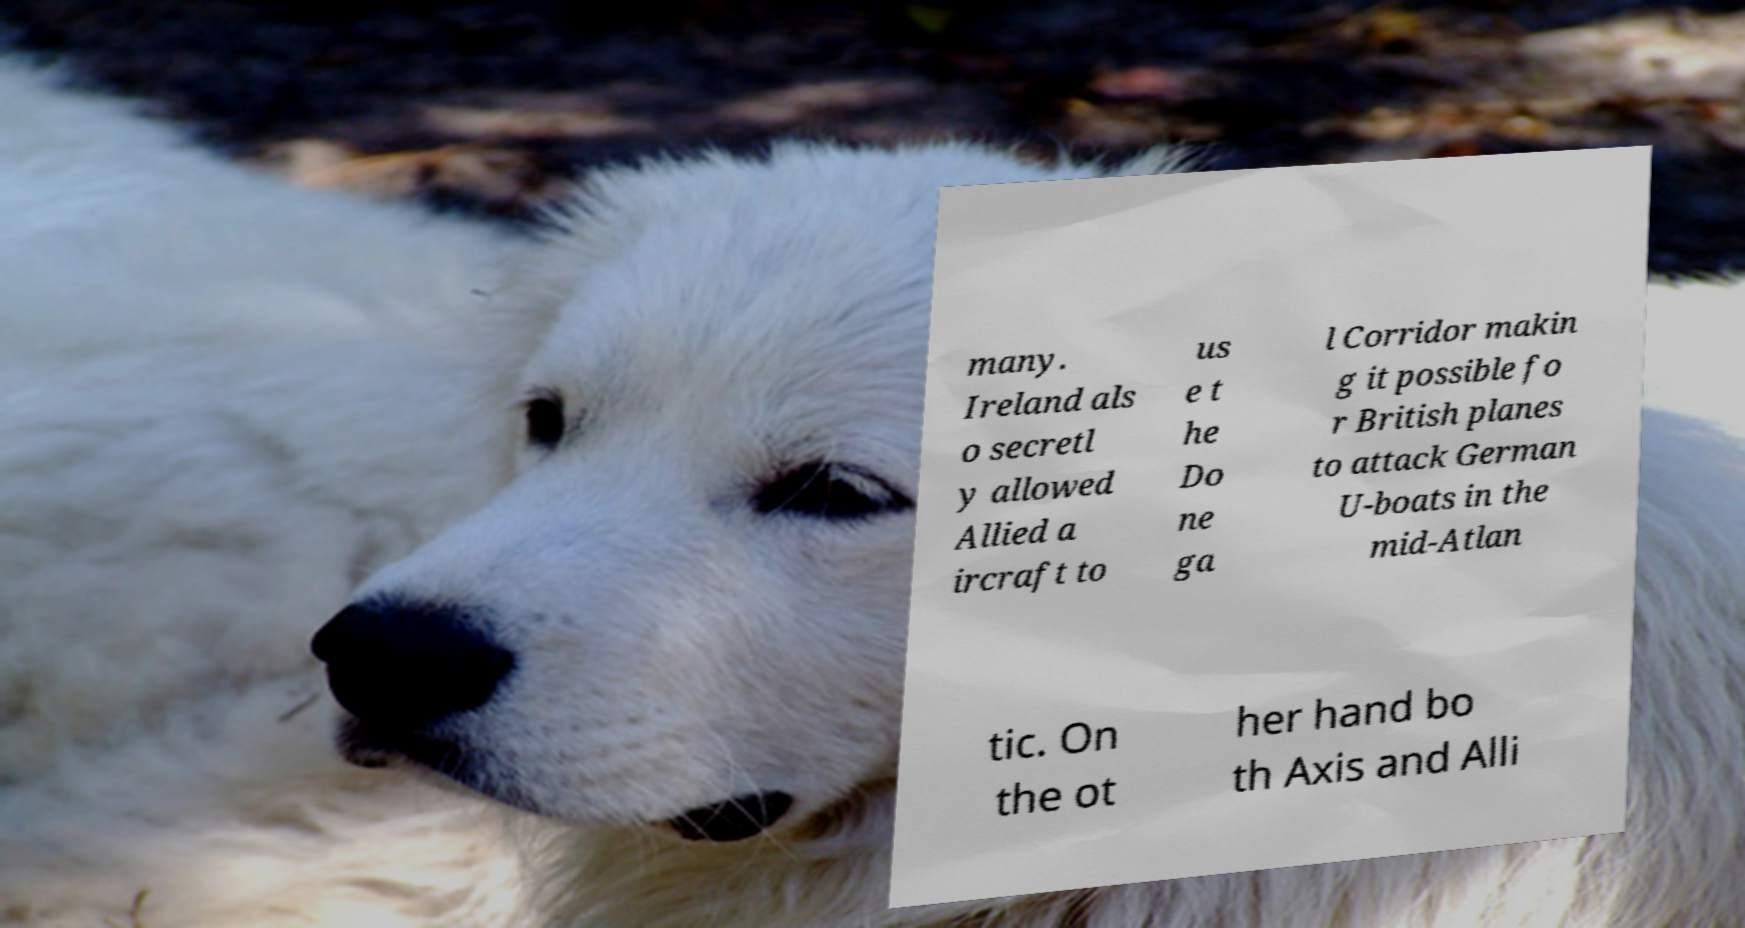I need the written content from this picture converted into text. Can you do that? many. Ireland als o secretl y allowed Allied a ircraft to us e t he Do ne ga l Corridor makin g it possible fo r British planes to attack German U-boats in the mid-Atlan tic. On the ot her hand bo th Axis and Alli 